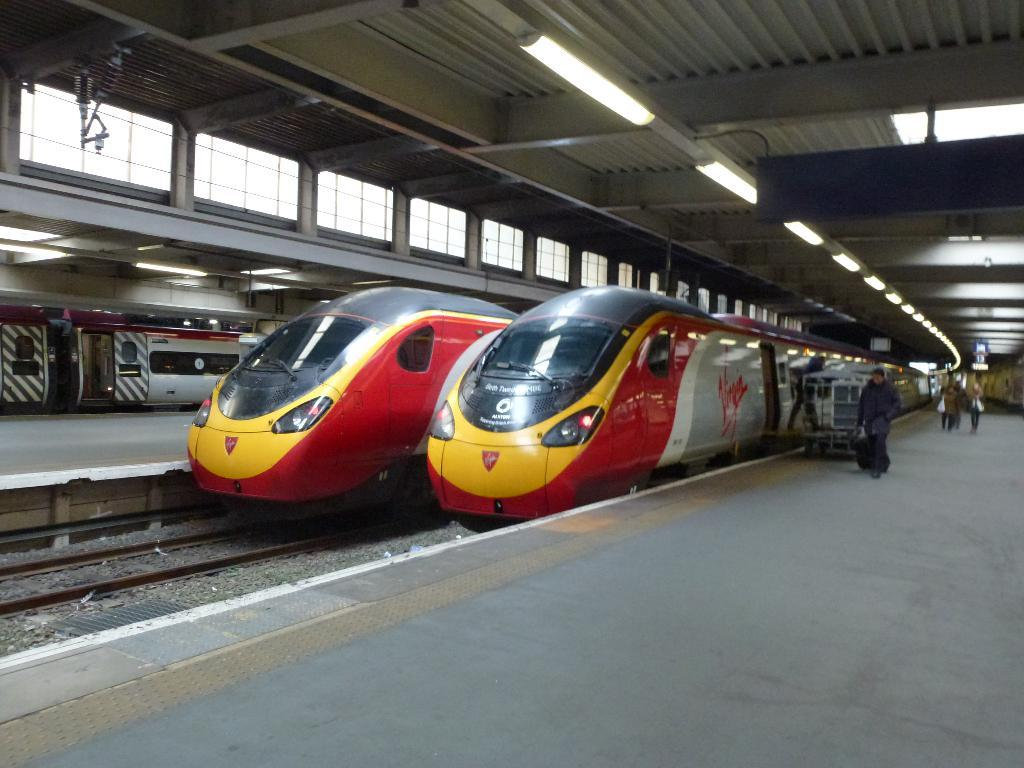<image>
Relay a brief, clear account of the picture shown. the word Virgin on the side of a train 